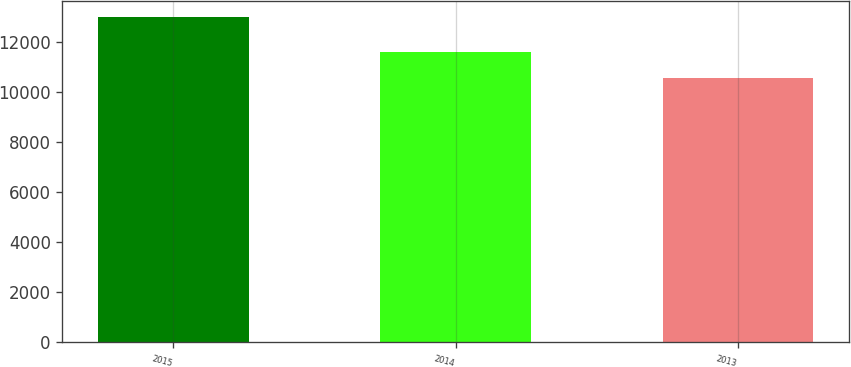<chart> <loc_0><loc_0><loc_500><loc_500><bar_chart><fcel>2015<fcel>2014<fcel>2013<nl><fcel>12984<fcel>11617<fcel>10578<nl></chart> 